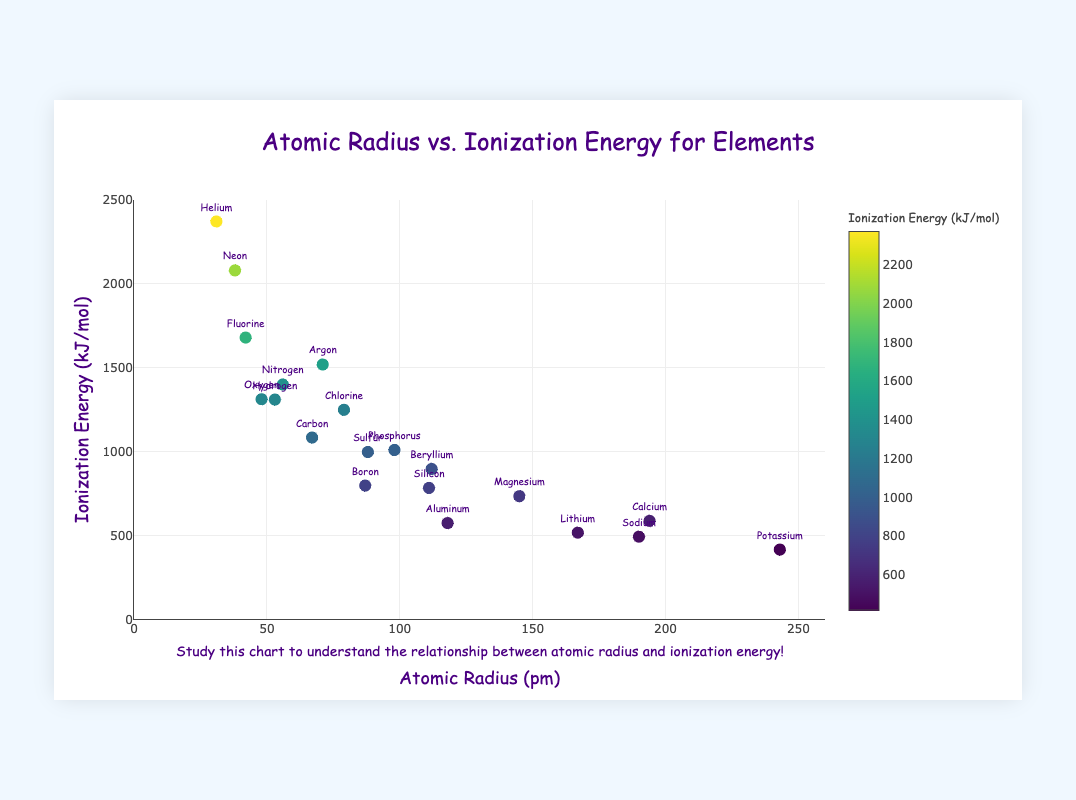What is the title of the scatter plot? The title of the scatter plot is typically displayed at the top of the chart. In this case, the title is provided in the layout details.
Answer: Atomic Radius vs. Ionization Energy for Elements What does the x-axis represent in this scatter plot? By looking at the axis labels, we can see that the x-axis represents the atomic radius in picometers (pm).
Answer: Atomic Radius (pm) Which element has the highest ionization energy? The element with the highest ionization energy corresponds to the highest y-value on the plot. Helium has the highest ionization energy of 2372 kJ/mol.
Answer: Helium Compare the atomic radius and ionization energy of Hydrogen and Helium. Which has a larger atomic radius and which has a higher ionization energy? By examining the specific data points, Hydrogen has an atomic radius of 53 pm and an ionization energy of 1312 kJ/mol, while Helium has an atomic radius of 31 pm and an ionization energy of 2372 kJ/mol. Helium has a smaller atomic radius and a higher ionization energy.
Answer: Helium has a smaller atomic radius and a higher ionization energy Which elemental group tends to have lower ionization energies, the alkali metals or the noble gases? Alkali metals (Li, Na, K) have lower ionization energies compared to noble gases (He, Ne, Ar) based on their positions on the y-axis.
Answer: Alkali metals What is the relationship between atomic radius and ionization energy as observed from the scatter plot? Generally, as the atomic radius increases, the ionization energy decreases. This inverse relationship can be seen from the distribution of points on the scatter plot.
Answer: Inverse relationship Identify the element with the largest atomic radius and provide its ionization energy. The element with the largest atomic radius is Potassium (243 pm), and its ionization energy is 419 kJ/mol.
Answer: Potassium, 419 kJ/mol What is the ionization energy of an element with an atomic radius of about 87 pm? By checking the data points around an atomic radius of 87 pm, Boron has an atomic radius of 87 pm and an ionization energy of 800 kJ/mol.
Answer: 800 kJ/mol Calculate the difference in ionization energy between Carbon and Oxygen. Carbon's ionization energy is 1086 kJ/mol and Oxygen's ionization energy is 1314 kJ/mol. The difference is 1314 - 1086 = 228 kJ/mol.
Answer: 228 kJ/mol How are the data points color-coded on this scatter plot? The data points are color-coded based on their ionization energy. The color scale used is 'Viridis', with specific values indicated on the colorbar. Higher ionization energies are displayed with different shades on the color scale.
Answer: Based on ionization energy 